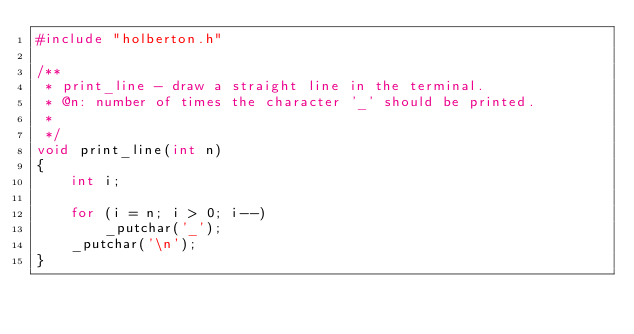<code> <loc_0><loc_0><loc_500><loc_500><_C_>#include "holberton.h"

/**
 * print_line - draw a straight line in the terminal.
 * @n: number of times the character '_' should be printed.
 *
 */
void print_line(int n)
{
	int i;

	for (i = n; i > 0; i--)
		_putchar('_');
	_putchar('\n');
}
</code> 